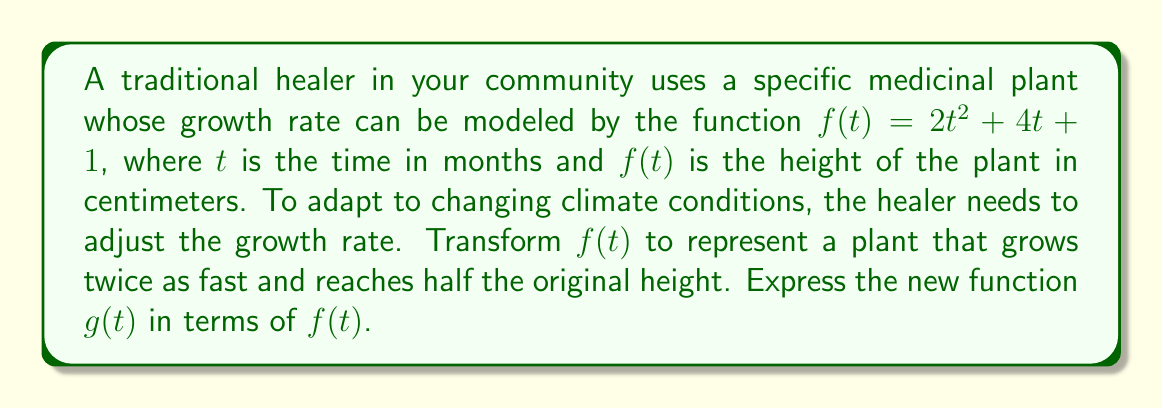Show me your answer to this math problem. To solve this problem, we need to apply two transformations to the original function $f(t)$:

1. To make the plant grow twice as fast, we need to compress the function horizontally by a factor of 2. This is done by replacing $t$ with $2t$ in the original function:
   $f(2t)$

2. To make the plant reach half the original height, we need to vertically compress the function by a factor of 1/2. This is done by multiplying the entire function by 1/2:
   $\frac{1}{2}f(2t)$

Combining these transformations, we get:

$g(t) = \frac{1}{2}f(2t)$

This new function $g(t)$ represents a plant that grows twice as fast and reaches half the original height compared to the plant represented by $f(t)$.
Answer: $g(t) = \frac{1}{2}f(2t)$ 